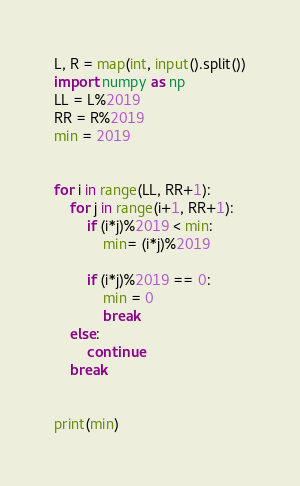Convert code to text. <code><loc_0><loc_0><loc_500><loc_500><_Python_>L, R = map(int, input().split())
import numpy as np
LL = L%2019
RR = R%2019
min = 2019


for i in range(LL, RR+1):
    for j in range(i+1, RR+1):
        if (i*j)%2019 < min:
            min= (i*j)%2019

        if (i*j)%2019 == 0:
            min = 0
            break
    else:
        continue
    break
        

print(min)</code> 